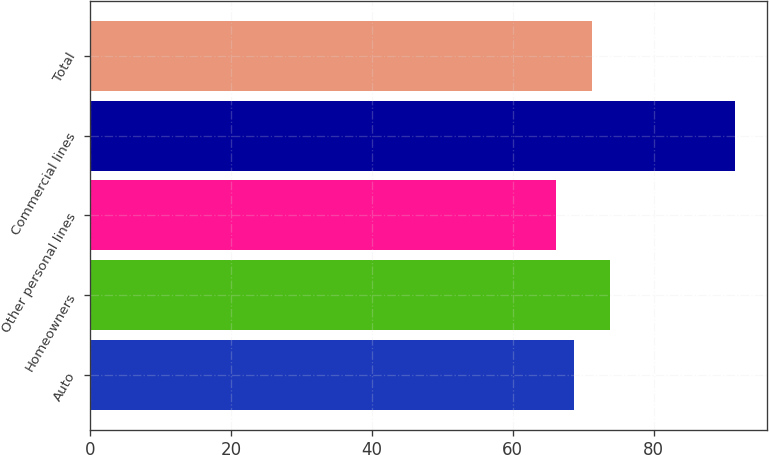<chart> <loc_0><loc_0><loc_500><loc_500><bar_chart><fcel>Auto<fcel>Homeowners<fcel>Other personal lines<fcel>Commercial lines<fcel>Total<nl><fcel>68.73<fcel>73.79<fcel>66.2<fcel>91.5<fcel>71.26<nl></chart> 